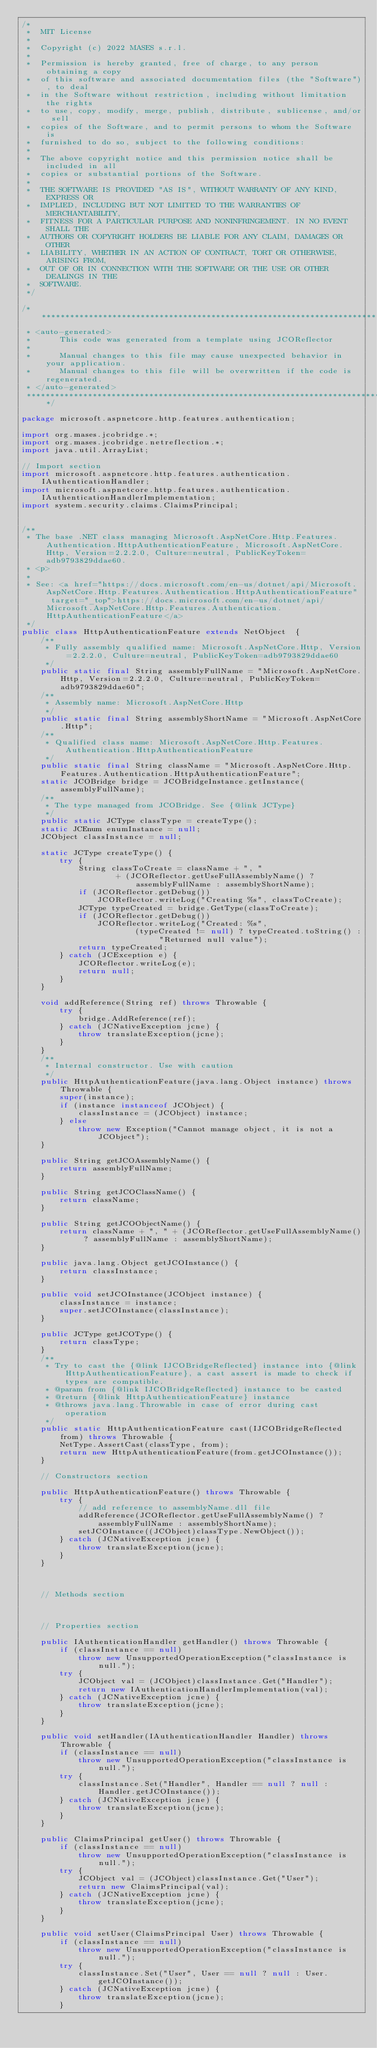<code> <loc_0><loc_0><loc_500><loc_500><_Java_>/*
 *  MIT License
 *
 *  Copyright (c) 2022 MASES s.r.l.
 *
 *  Permission is hereby granted, free of charge, to any person obtaining a copy
 *  of this software and associated documentation files (the "Software"), to deal
 *  in the Software without restriction, including without limitation the rights
 *  to use, copy, modify, merge, publish, distribute, sublicense, and/or sell
 *  copies of the Software, and to permit persons to whom the Software is
 *  furnished to do so, subject to the following conditions:
 *
 *  The above copyright notice and this permission notice shall be included in all
 *  copies or substantial portions of the Software.
 *
 *  THE SOFTWARE IS PROVIDED "AS IS", WITHOUT WARRANTY OF ANY KIND, EXPRESS OR
 *  IMPLIED, INCLUDING BUT NOT LIMITED TO THE WARRANTIES OF MERCHANTABILITY,
 *  FITNESS FOR A PARTICULAR PURPOSE AND NONINFRINGEMENT. IN NO EVENT SHALL THE
 *  AUTHORS OR COPYRIGHT HOLDERS BE LIABLE FOR ANY CLAIM, DAMAGES OR OTHER
 *  LIABILITY, WHETHER IN AN ACTION OF CONTRACT, TORT OR OTHERWISE, ARISING FROM,
 *  OUT OF OR IN CONNECTION WITH THE SOFTWARE OR THE USE OR OTHER DEALINGS IN THE
 *  SOFTWARE.
 */

/**************************************************************************************
 * <auto-generated>
 *      This code was generated from a template using JCOReflector
 * 
 *      Manual changes to this file may cause unexpected behavior in your application.
 *      Manual changes to this file will be overwritten if the code is regenerated.
 * </auto-generated>
 *************************************************************************************/

package microsoft.aspnetcore.http.features.authentication;

import org.mases.jcobridge.*;
import org.mases.jcobridge.netreflection.*;
import java.util.ArrayList;

// Import section
import microsoft.aspnetcore.http.features.authentication.IAuthenticationHandler;
import microsoft.aspnetcore.http.features.authentication.IAuthenticationHandlerImplementation;
import system.security.claims.ClaimsPrincipal;


/**
 * The base .NET class managing Microsoft.AspNetCore.Http.Features.Authentication.HttpAuthenticationFeature, Microsoft.AspNetCore.Http, Version=2.2.2.0, Culture=neutral, PublicKeyToken=adb9793829ddae60.
 * <p>
 * 
 * See: <a href="https://docs.microsoft.com/en-us/dotnet/api/Microsoft.AspNetCore.Http.Features.Authentication.HttpAuthenticationFeature" target="_top">https://docs.microsoft.com/en-us/dotnet/api/Microsoft.AspNetCore.Http.Features.Authentication.HttpAuthenticationFeature</a>
 */
public class HttpAuthenticationFeature extends NetObject  {
    /**
     * Fully assembly qualified name: Microsoft.AspNetCore.Http, Version=2.2.2.0, Culture=neutral, PublicKeyToken=adb9793829ddae60
     */
    public static final String assemblyFullName = "Microsoft.AspNetCore.Http, Version=2.2.2.0, Culture=neutral, PublicKeyToken=adb9793829ddae60";
    /**
     * Assembly name: Microsoft.AspNetCore.Http
     */
    public static final String assemblyShortName = "Microsoft.AspNetCore.Http";
    /**
     * Qualified class name: Microsoft.AspNetCore.Http.Features.Authentication.HttpAuthenticationFeature
     */
    public static final String className = "Microsoft.AspNetCore.Http.Features.Authentication.HttpAuthenticationFeature";
    static JCOBridge bridge = JCOBridgeInstance.getInstance(assemblyFullName);
    /**
     * The type managed from JCOBridge. See {@link JCType}
     */
    public static JCType classType = createType();
    static JCEnum enumInstance = null;
    JCObject classInstance = null;

    static JCType createType() {
        try {
            String classToCreate = className + ", "
                    + (JCOReflector.getUseFullAssemblyName() ? assemblyFullName : assemblyShortName);
            if (JCOReflector.getDebug())
                JCOReflector.writeLog("Creating %s", classToCreate);
            JCType typeCreated = bridge.GetType(classToCreate);
            if (JCOReflector.getDebug())
                JCOReflector.writeLog("Created: %s",
                        (typeCreated != null) ? typeCreated.toString() : "Returned null value");
            return typeCreated;
        } catch (JCException e) {
            JCOReflector.writeLog(e);
            return null;
        }
    }

    void addReference(String ref) throws Throwable {
        try {
            bridge.AddReference(ref);
        } catch (JCNativeException jcne) {
            throw translateException(jcne);
        }
    }
    /**
     * Internal constructor. Use with caution 
     */
    public HttpAuthenticationFeature(java.lang.Object instance) throws Throwable {
        super(instance);
        if (instance instanceof JCObject) {
            classInstance = (JCObject) instance;
        } else
            throw new Exception("Cannot manage object, it is not a JCObject");
    }

    public String getJCOAssemblyName() {
        return assemblyFullName;
    }

    public String getJCOClassName() {
        return className;
    }

    public String getJCOObjectName() {
        return className + ", " + (JCOReflector.getUseFullAssemblyName() ? assemblyFullName : assemblyShortName);
    }

    public java.lang.Object getJCOInstance() {
        return classInstance;
    }

    public void setJCOInstance(JCObject instance) {
        classInstance = instance;
        super.setJCOInstance(classInstance);
    }

    public JCType getJCOType() {
        return classType;
    }
    /**
     * Try to cast the {@link IJCOBridgeReflected} instance into {@link HttpAuthenticationFeature}, a cast assert is made to check if types are compatible.
     * @param from {@link IJCOBridgeReflected} instance to be casted
     * @return {@link HttpAuthenticationFeature} instance
     * @throws java.lang.Throwable in case of error during cast operation
     */
    public static HttpAuthenticationFeature cast(IJCOBridgeReflected from) throws Throwable {
        NetType.AssertCast(classType, from);
        return new HttpAuthenticationFeature(from.getJCOInstance());
    }

    // Constructors section
    
    public HttpAuthenticationFeature() throws Throwable {
        try {
            // add reference to assemblyName.dll file
            addReference(JCOReflector.getUseFullAssemblyName() ? assemblyFullName : assemblyShortName);
            setJCOInstance((JCObject)classType.NewObject());
        } catch (JCNativeException jcne) {
            throw translateException(jcne);
        }
    }


    
    // Methods section
    

    
    // Properties section
    
    public IAuthenticationHandler getHandler() throws Throwable {
        if (classInstance == null)
            throw new UnsupportedOperationException("classInstance is null.");
        try {
            JCObject val = (JCObject)classInstance.Get("Handler");
            return new IAuthenticationHandlerImplementation(val);
        } catch (JCNativeException jcne) {
            throw translateException(jcne);
        }
    }

    public void setHandler(IAuthenticationHandler Handler) throws Throwable {
        if (classInstance == null)
            throw new UnsupportedOperationException("classInstance is null.");
        try {
            classInstance.Set("Handler", Handler == null ? null : Handler.getJCOInstance());
        } catch (JCNativeException jcne) {
            throw translateException(jcne);
        }
    }

    public ClaimsPrincipal getUser() throws Throwable {
        if (classInstance == null)
            throw new UnsupportedOperationException("classInstance is null.");
        try {
            JCObject val = (JCObject)classInstance.Get("User");
            return new ClaimsPrincipal(val);
        } catch (JCNativeException jcne) {
            throw translateException(jcne);
        }
    }

    public void setUser(ClaimsPrincipal User) throws Throwable {
        if (classInstance == null)
            throw new UnsupportedOperationException("classInstance is null.");
        try {
            classInstance.Set("User", User == null ? null : User.getJCOInstance());
        } catch (JCNativeException jcne) {
            throw translateException(jcne);
        }</code> 